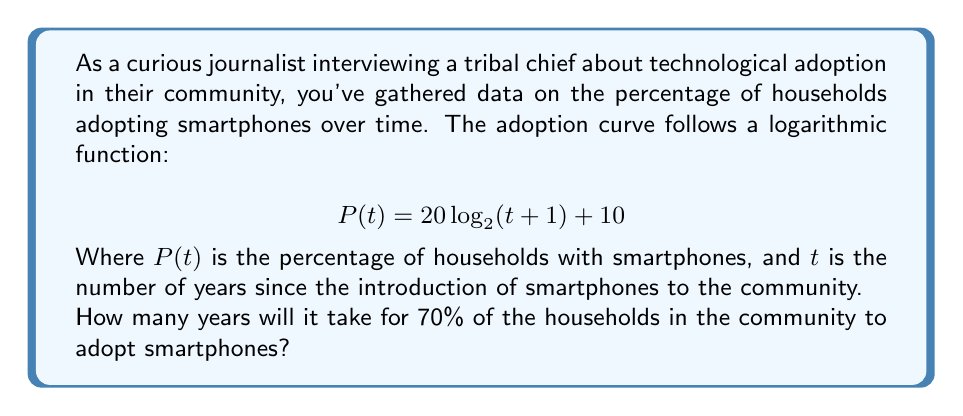Help me with this question. To solve this problem, we need to follow these steps:

1) We're looking for the time $t$ when $P(t) = 70\%$. So, we set up the equation:

   $$70 = 20 \log_{2}(t+1) + 10$$

2) Subtract 10 from both sides:

   $$60 = 20 \log_{2}(t+1)$$

3) Divide both sides by 20:

   $$3 = \log_{2}(t+1)$$

4) To solve for $t$, we need to apply the inverse function (exponential) to both sides:

   $$2^3 = t+1$$

5) Simplify the left side:

   $$8 = t+1$$

6) Subtract 1 from both sides to isolate $t$:

   $$7 = t$$

Therefore, it will take 7 years for 70% of the households to adopt smartphones.

This logarithmic model reflects the typical S-curve of technology adoption, where adoption is slow at first, then accelerates, and finally slows down as it approaches saturation.
Answer: 7 years 